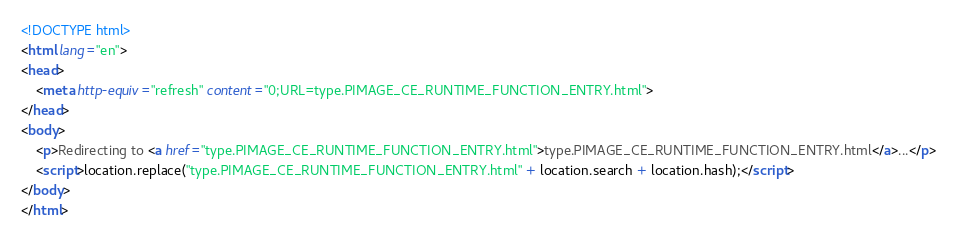<code> <loc_0><loc_0><loc_500><loc_500><_HTML_><!DOCTYPE html>
<html lang="en">
<head>
    <meta http-equiv="refresh" content="0;URL=type.PIMAGE_CE_RUNTIME_FUNCTION_ENTRY.html">
</head>
<body>
    <p>Redirecting to <a href="type.PIMAGE_CE_RUNTIME_FUNCTION_ENTRY.html">type.PIMAGE_CE_RUNTIME_FUNCTION_ENTRY.html</a>...</p>
    <script>location.replace("type.PIMAGE_CE_RUNTIME_FUNCTION_ENTRY.html" + location.search + location.hash);</script>
</body>
</html></code> 